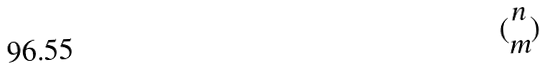Convert formula to latex. <formula><loc_0><loc_0><loc_500><loc_500>( \begin{matrix} n \\ m \end{matrix} )</formula> 